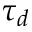Convert formula to latex. <formula><loc_0><loc_0><loc_500><loc_500>\tau _ { d }</formula> 